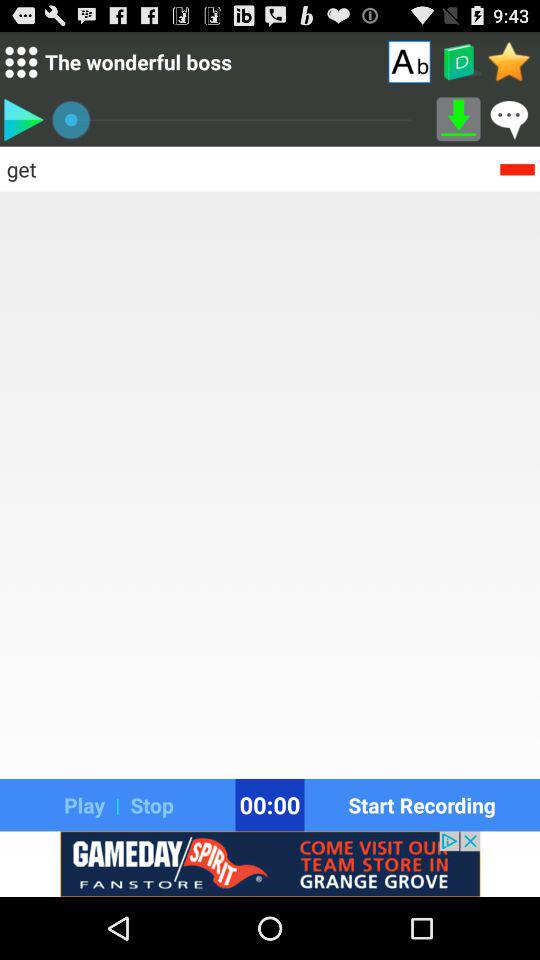What is the duration of the recording shown there? The duration is 0 minutes 0 seconds. 